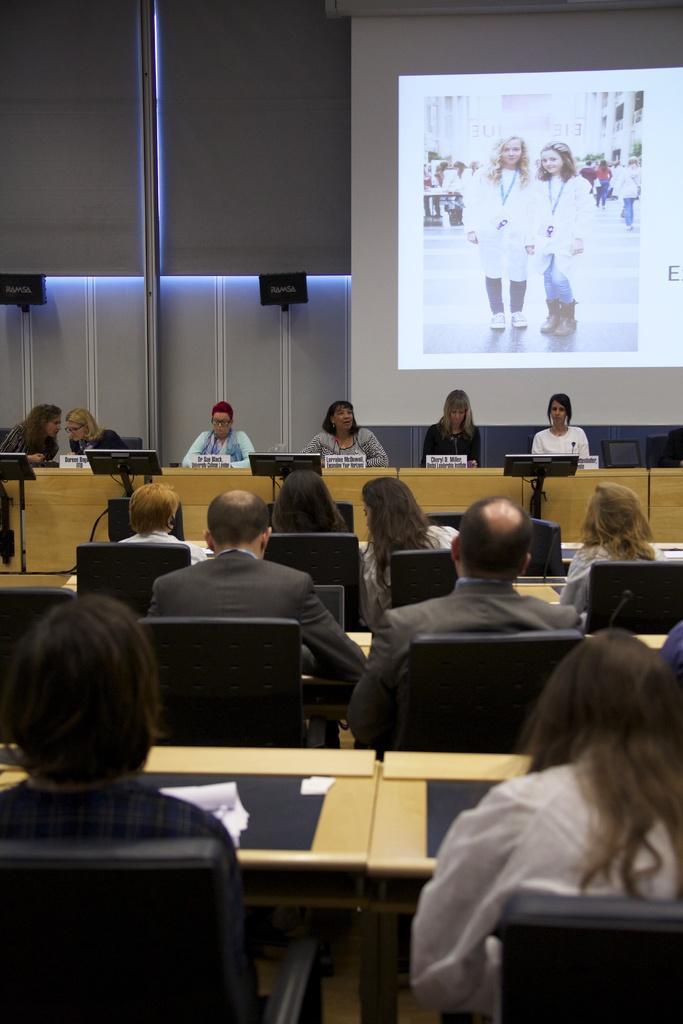How would you summarize this image in a sentence or two? There is a group of people. They are sitting on a chair. We can see the background is projector. 